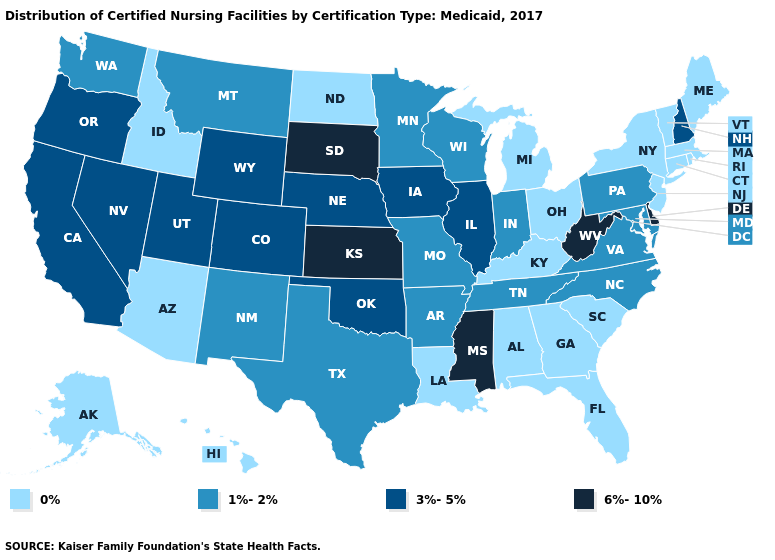What is the value of Missouri?
Keep it brief. 1%-2%. Among the states that border Arkansas , does Texas have the highest value?
Short answer required. No. What is the value of Rhode Island?
Write a very short answer. 0%. Name the states that have a value in the range 6%-10%?
Give a very brief answer. Delaware, Kansas, Mississippi, South Dakota, West Virginia. Which states have the highest value in the USA?
Keep it brief. Delaware, Kansas, Mississippi, South Dakota, West Virginia. Name the states that have a value in the range 6%-10%?
Give a very brief answer. Delaware, Kansas, Mississippi, South Dakota, West Virginia. Does New York have the highest value in the USA?
Write a very short answer. No. What is the highest value in the USA?
Be succinct. 6%-10%. What is the value of Virginia?
Give a very brief answer. 1%-2%. What is the lowest value in the USA?
Keep it brief. 0%. Name the states that have a value in the range 0%?
Short answer required. Alabama, Alaska, Arizona, Connecticut, Florida, Georgia, Hawaii, Idaho, Kentucky, Louisiana, Maine, Massachusetts, Michigan, New Jersey, New York, North Dakota, Ohio, Rhode Island, South Carolina, Vermont. Which states hav the highest value in the Northeast?
Write a very short answer. New Hampshire. Does Oklahoma have the lowest value in the South?
Be succinct. No. Does Virginia have the lowest value in the USA?
Keep it brief. No. Does Alabama have the lowest value in the USA?
Keep it brief. Yes. 